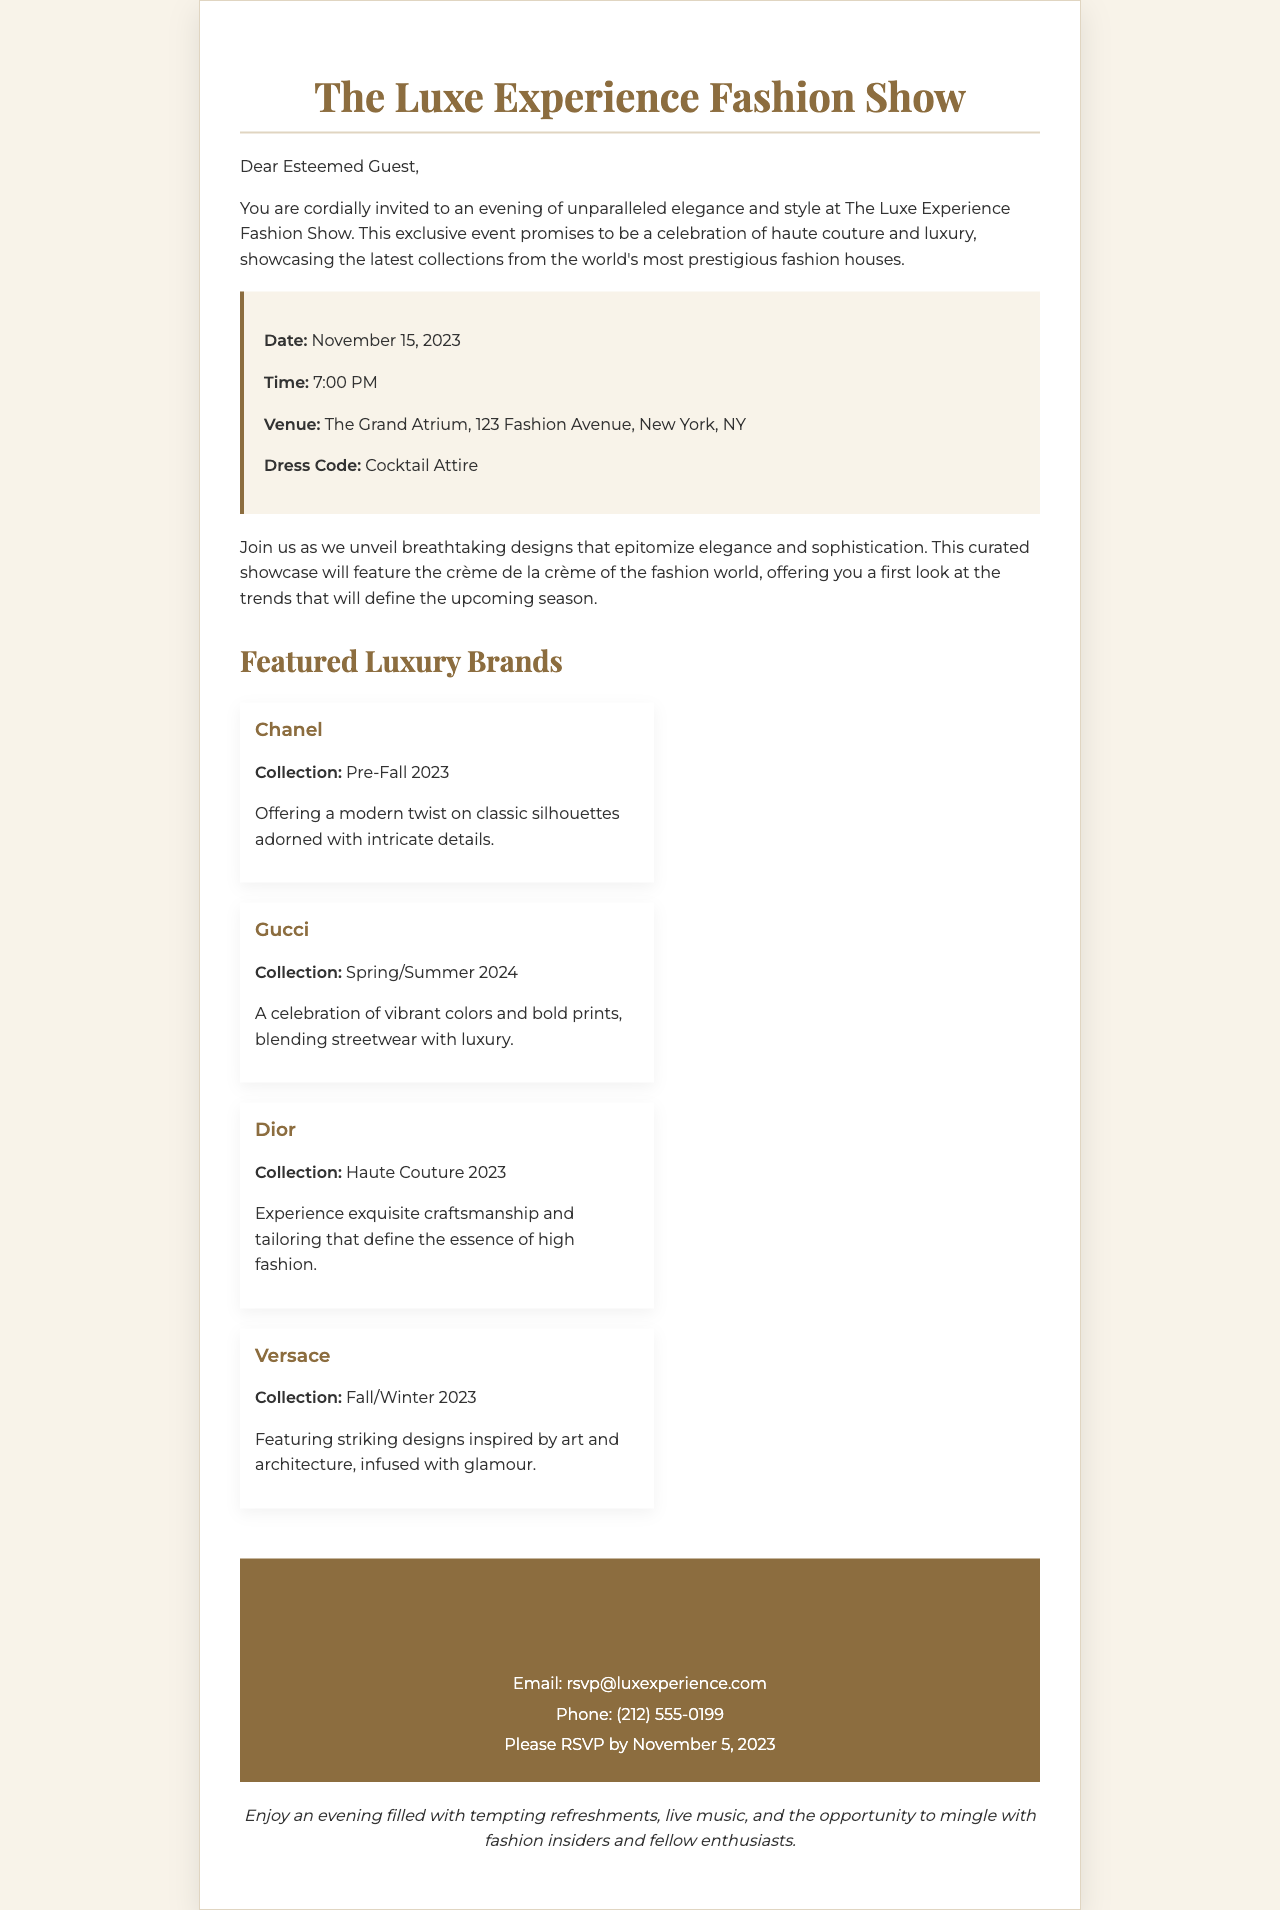What is the date of the fashion show? The date of the fashion show is specified in the event details section of the document.
Answer: November 15, 2023 What is the venue for the event? The venue is mentioned in the event details section, providing a specific address.
Answer: The Grand Atrium, 123 Fashion Avenue, New York, NY What time does the fashion show start? The starting time of the event is clearly stated in the document.
Answer: 7:00 PM Which brand is featuring a Pre-Fall 2023 collection? This question combines knowledge about the brands and their respective collections from the document.
Answer: Chanel What is the dress code for the event? The dress code is listed explicitly in the event details section.
Answer: Cocktail Attire How can guests RSVP to the event? The RSVP information is provided in the RSVP section of the document, indicating how to respond.
Answer: Email or Phone What collection is Gucci showcasing? This question requires knowledge of the specific brand's collection mentioned in the document.
Answer: Spring/Summer 2024 By what date should guests RSVP? The RSVP deadline is stated in the RSVP section, which is crucial for potential attendees.
Answer: November 5, 2023 What type of refreshments will be available? This question refers to the additional information provided at the end of the invitation regarding the event atmosphere.
Answer: Tempting refreshments 